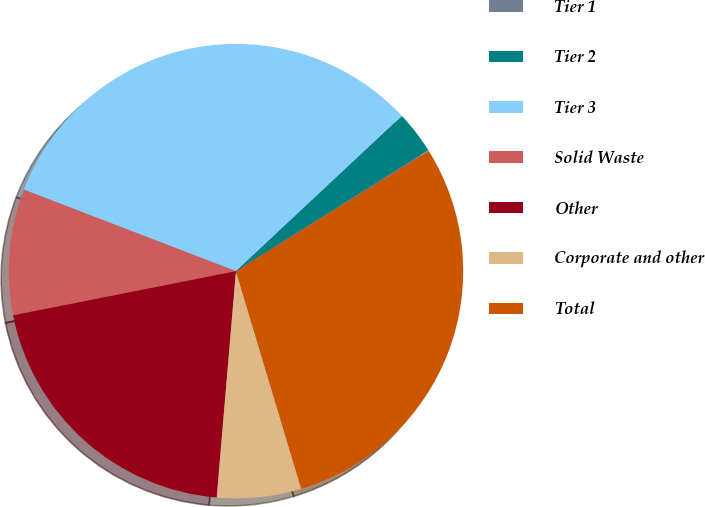Convert chart. <chart><loc_0><loc_0><loc_500><loc_500><pie_chart><fcel>Tier 1<fcel>Tier 2<fcel>Tier 3<fcel>Solid Waste<fcel>Other<fcel>Corporate and other<fcel>Total<nl><fcel>0.07%<fcel>3.03%<fcel>32.19%<fcel>8.95%<fcel>20.54%<fcel>5.99%<fcel>29.23%<nl></chart> 